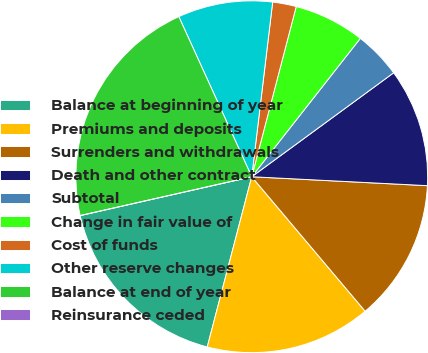<chart> <loc_0><loc_0><loc_500><loc_500><pie_chart><fcel>Balance at beginning of year<fcel>Premiums and deposits<fcel>Surrenders and withdrawals<fcel>Death and other contract<fcel>Subtotal<fcel>Change in fair value of<fcel>Cost of funds<fcel>Other reserve changes<fcel>Balance at end of year<fcel>Reinsurance ceded<nl><fcel>17.39%<fcel>15.22%<fcel>13.04%<fcel>10.87%<fcel>4.35%<fcel>6.52%<fcel>2.17%<fcel>8.7%<fcel>21.74%<fcel>0.0%<nl></chart> 